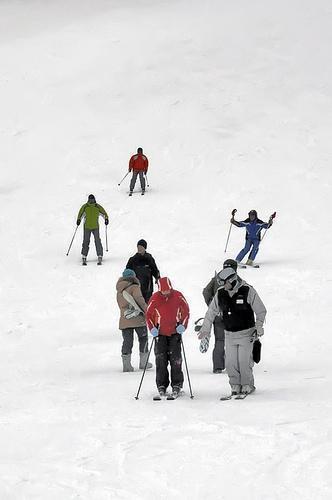What is the man in grey pants doing?
Select the accurate answer and provide justification: `Answer: choice
Rationale: srationale.`
Options: Coaching, joking, complaining, singing. Answer: coaching.
Rationale: The man is coaching. 